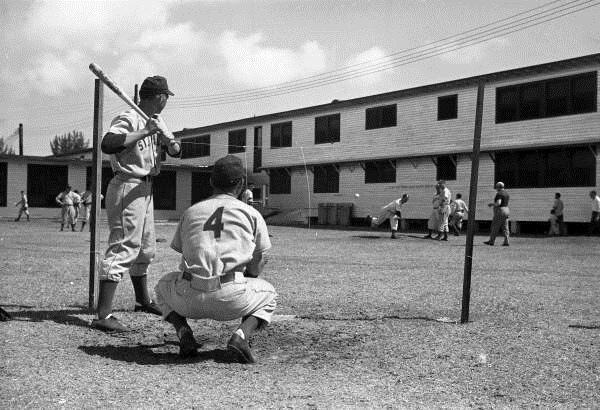How many people are visible?
Give a very brief answer. 2. How many zebras are in the photo?
Give a very brief answer. 0. 